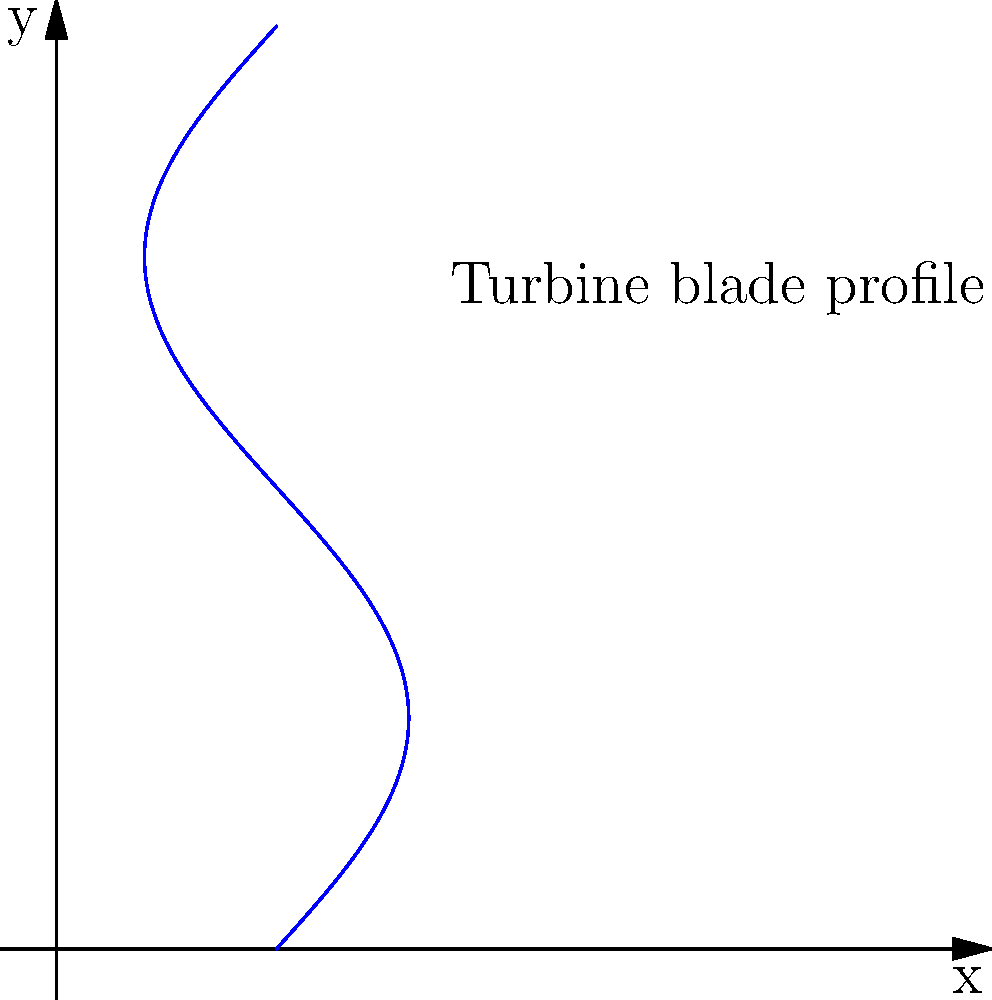A turbine blade profile is represented by the parametric equations:

$$x = 0.5 + 0.3\sin(t)$$
$$y = \frac{t}{3}$$

where $t$ is the parameter varying from 0 to $2\pi$. Calculate the maximum curvature of the blade profile to optimize its aerodynamic properties. To find the maximum curvature, we need to follow these steps:

1) The curvature formula for a parametric curve is:

   $$\kappa = \frac{|x'y'' - y'x''|}{(x'^2 + y'^2)^{3/2}}$$

2) Calculate the first derivatives:
   $$x' = 0.3\cos(t)$$
   $$y' = \frac{1}{3}$$

3) Calculate the second derivatives:
   $$x'' = -0.3\sin(t)$$
   $$y'' = 0$$

4) Substitute into the curvature formula:

   $$\kappa = \frac{|0.3\cos(t) \cdot 0 - \frac{1}{3} \cdot (-0.3\sin(t))|}{((0.3\cos(t))^2 + (\frac{1}{3})^2)^{3/2}}$$

5) Simplify:

   $$\kappa = \frac{0.1\sin(t)}{(0.09\cos^2(t) + \frac{1}{9})^{3/2}}$$

6) To find the maximum, we need to find where the derivative of $\kappa$ with respect to $t$ is zero. However, this leads to a complex equation.

7) Instead, we can observe that $\sin(t)$ reaches its maximum at $t = \frac{\pi}{2}$ and $\frac{3\pi}{2}$, and $\cos(t)$ is zero at these points.

8) Evaluating $\kappa$ at $t = \frac{\pi}{2}$:

   $$\kappa_{max} = \frac{0.1}{(\frac{1}{9})^{3/2}} = 0.1 \cdot 27 = 2.7$$

Therefore, the maximum curvature of the blade profile is 2.7.
Answer: 2.7 